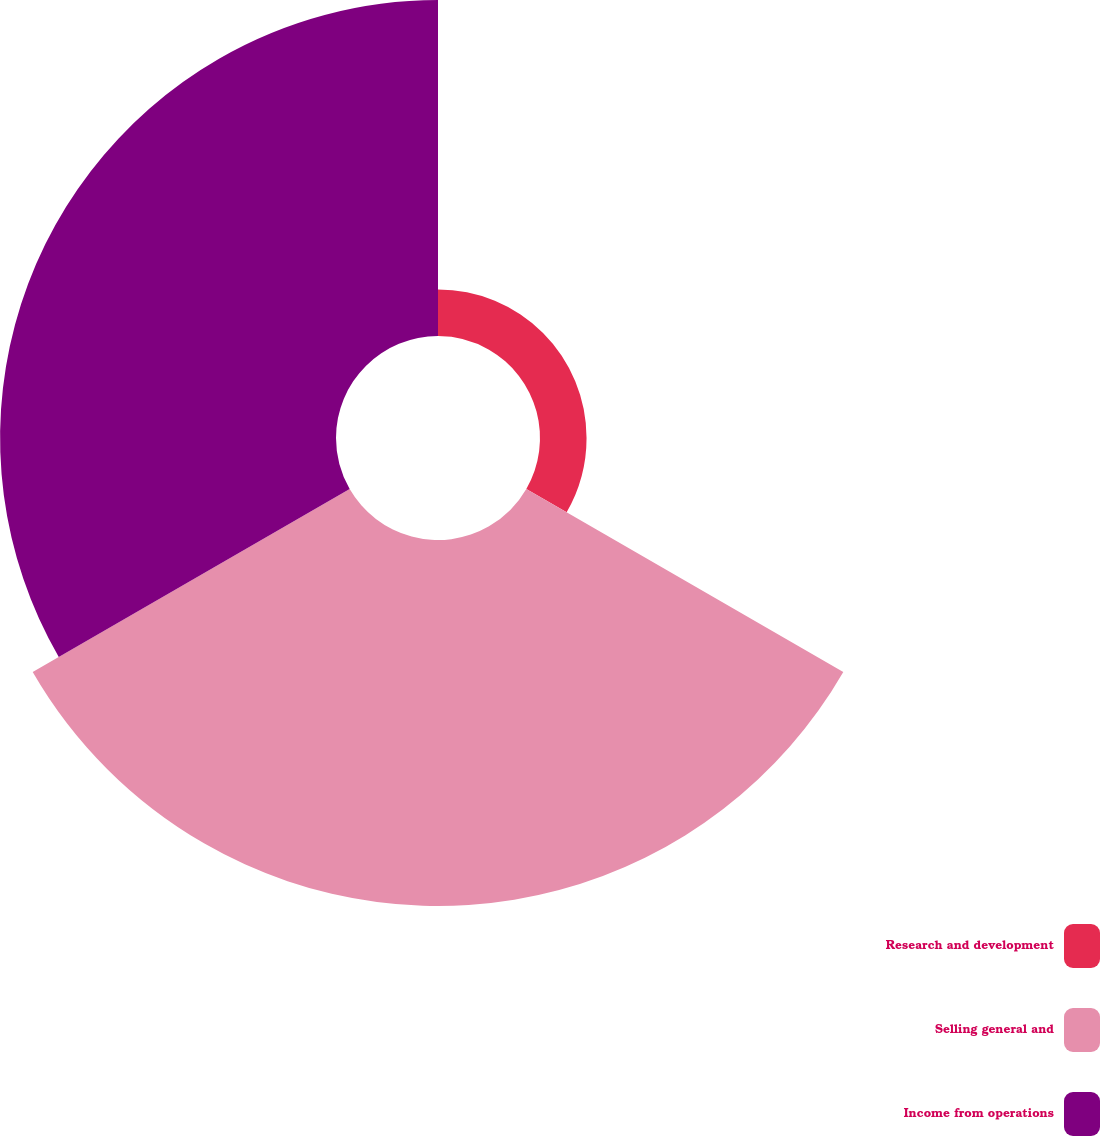Convert chart to OTSL. <chart><loc_0><loc_0><loc_500><loc_500><pie_chart><fcel>Research and development<fcel>Selling general and<fcel>Income from operations<nl><fcel>6.22%<fcel>48.9%<fcel>44.88%<nl></chart> 